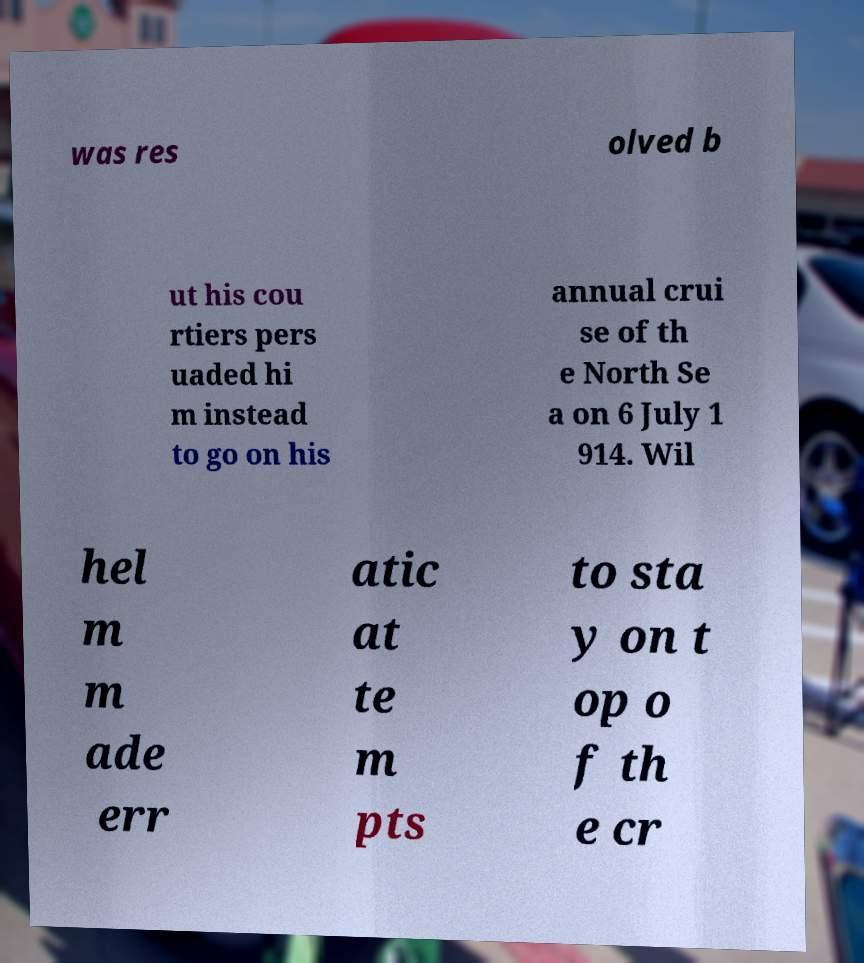Can you accurately transcribe the text from the provided image for me? was res olved b ut his cou rtiers pers uaded hi m instead to go on his annual crui se of th e North Se a on 6 July 1 914. Wil hel m m ade err atic at te m pts to sta y on t op o f th e cr 